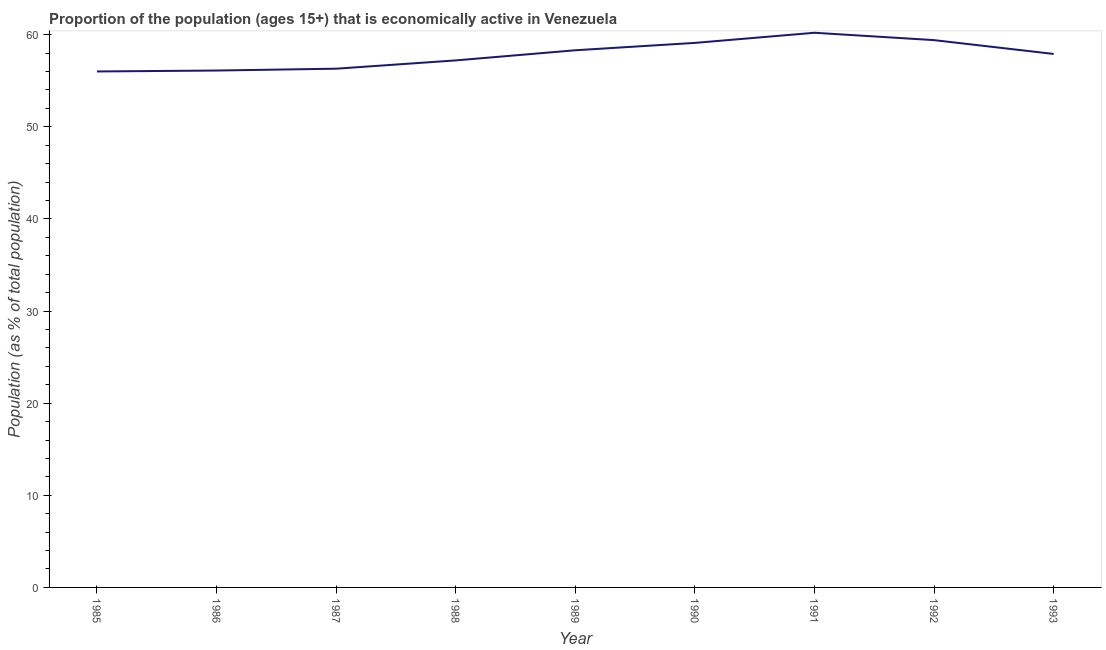What is the percentage of economically active population in 1992?
Ensure brevity in your answer.  59.4. Across all years, what is the maximum percentage of economically active population?
Provide a short and direct response. 60.2. Across all years, what is the minimum percentage of economically active population?
Make the answer very short. 56. What is the sum of the percentage of economically active population?
Make the answer very short. 520.5. What is the difference between the percentage of economically active population in 1986 and 1989?
Your answer should be very brief. -2.2. What is the average percentage of economically active population per year?
Keep it short and to the point. 57.83. What is the median percentage of economically active population?
Ensure brevity in your answer.  57.9. In how many years, is the percentage of economically active population greater than 28 %?
Provide a succinct answer. 9. Do a majority of the years between 1990 and 1989 (inclusive) have percentage of economically active population greater than 52 %?
Your answer should be compact. No. What is the ratio of the percentage of economically active population in 1988 to that in 1989?
Provide a succinct answer. 0.98. Is the percentage of economically active population in 1990 less than that in 1992?
Keep it short and to the point. Yes. Is the difference between the percentage of economically active population in 1990 and 1992 greater than the difference between any two years?
Offer a very short reply. No. What is the difference between the highest and the second highest percentage of economically active population?
Keep it short and to the point. 0.8. Is the sum of the percentage of economically active population in 1987 and 1989 greater than the maximum percentage of economically active population across all years?
Your answer should be very brief. Yes. What is the difference between the highest and the lowest percentage of economically active population?
Your answer should be compact. 4.2. In how many years, is the percentage of economically active population greater than the average percentage of economically active population taken over all years?
Provide a short and direct response. 5. How many lines are there?
Offer a very short reply. 1. Does the graph contain any zero values?
Provide a short and direct response. No. Does the graph contain grids?
Your response must be concise. No. What is the title of the graph?
Offer a terse response. Proportion of the population (ages 15+) that is economically active in Venezuela. What is the label or title of the Y-axis?
Provide a succinct answer. Population (as % of total population). What is the Population (as % of total population) of 1985?
Your response must be concise. 56. What is the Population (as % of total population) in 1986?
Offer a terse response. 56.1. What is the Population (as % of total population) of 1987?
Your answer should be very brief. 56.3. What is the Population (as % of total population) in 1988?
Keep it short and to the point. 57.2. What is the Population (as % of total population) in 1989?
Keep it short and to the point. 58.3. What is the Population (as % of total population) of 1990?
Provide a succinct answer. 59.1. What is the Population (as % of total population) of 1991?
Give a very brief answer. 60.2. What is the Population (as % of total population) in 1992?
Keep it short and to the point. 59.4. What is the Population (as % of total population) of 1993?
Your answer should be compact. 57.9. What is the difference between the Population (as % of total population) in 1985 and 1989?
Your answer should be very brief. -2.3. What is the difference between the Population (as % of total population) in 1985 and 1990?
Offer a terse response. -3.1. What is the difference between the Population (as % of total population) in 1985 and 1991?
Offer a terse response. -4.2. What is the difference between the Population (as % of total population) in 1985 and 1992?
Ensure brevity in your answer.  -3.4. What is the difference between the Population (as % of total population) in 1985 and 1993?
Give a very brief answer. -1.9. What is the difference between the Population (as % of total population) in 1986 and 1987?
Provide a short and direct response. -0.2. What is the difference between the Population (as % of total population) in 1986 and 1988?
Keep it short and to the point. -1.1. What is the difference between the Population (as % of total population) in 1986 and 1989?
Ensure brevity in your answer.  -2.2. What is the difference between the Population (as % of total population) in 1986 and 1991?
Keep it short and to the point. -4.1. What is the difference between the Population (as % of total population) in 1986 and 1993?
Give a very brief answer. -1.8. What is the difference between the Population (as % of total population) in 1987 and 1993?
Ensure brevity in your answer.  -1.6. What is the difference between the Population (as % of total population) in 1988 and 1989?
Make the answer very short. -1.1. What is the difference between the Population (as % of total population) in 1988 and 1991?
Your response must be concise. -3. What is the difference between the Population (as % of total population) in 1988 and 1992?
Provide a succinct answer. -2.2. What is the difference between the Population (as % of total population) in 1989 and 1992?
Keep it short and to the point. -1.1. What is the difference between the Population (as % of total population) in 1989 and 1993?
Provide a succinct answer. 0.4. What is the difference between the Population (as % of total population) in 1990 and 1992?
Your answer should be very brief. -0.3. What is the difference between the Population (as % of total population) in 1990 and 1993?
Your answer should be very brief. 1.2. What is the difference between the Population (as % of total population) in 1991 and 1992?
Keep it short and to the point. 0.8. What is the difference between the Population (as % of total population) in 1991 and 1993?
Your response must be concise. 2.3. What is the ratio of the Population (as % of total population) in 1985 to that in 1986?
Keep it short and to the point. 1. What is the ratio of the Population (as % of total population) in 1985 to that in 1988?
Offer a very short reply. 0.98. What is the ratio of the Population (as % of total population) in 1985 to that in 1990?
Offer a terse response. 0.95. What is the ratio of the Population (as % of total population) in 1985 to that in 1991?
Give a very brief answer. 0.93. What is the ratio of the Population (as % of total population) in 1985 to that in 1992?
Provide a succinct answer. 0.94. What is the ratio of the Population (as % of total population) in 1985 to that in 1993?
Provide a succinct answer. 0.97. What is the ratio of the Population (as % of total population) in 1986 to that in 1987?
Offer a terse response. 1. What is the ratio of the Population (as % of total population) in 1986 to that in 1990?
Ensure brevity in your answer.  0.95. What is the ratio of the Population (as % of total population) in 1986 to that in 1991?
Your answer should be compact. 0.93. What is the ratio of the Population (as % of total population) in 1986 to that in 1992?
Keep it short and to the point. 0.94. What is the ratio of the Population (as % of total population) in 1986 to that in 1993?
Your response must be concise. 0.97. What is the ratio of the Population (as % of total population) in 1987 to that in 1988?
Keep it short and to the point. 0.98. What is the ratio of the Population (as % of total population) in 1987 to that in 1989?
Offer a very short reply. 0.97. What is the ratio of the Population (as % of total population) in 1987 to that in 1990?
Offer a terse response. 0.95. What is the ratio of the Population (as % of total population) in 1987 to that in 1991?
Your answer should be very brief. 0.94. What is the ratio of the Population (as % of total population) in 1987 to that in 1992?
Provide a short and direct response. 0.95. What is the ratio of the Population (as % of total population) in 1988 to that in 1990?
Your response must be concise. 0.97. What is the ratio of the Population (as % of total population) in 1989 to that in 1990?
Give a very brief answer. 0.99. What is the ratio of the Population (as % of total population) in 1990 to that in 1992?
Keep it short and to the point. 0.99. What is the ratio of the Population (as % of total population) in 1990 to that in 1993?
Your response must be concise. 1.02. What is the ratio of the Population (as % of total population) in 1991 to that in 1992?
Your answer should be very brief. 1.01. What is the ratio of the Population (as % of total population) in 1991 to that in 1993?
Provide a short and direct response. 1.04. 